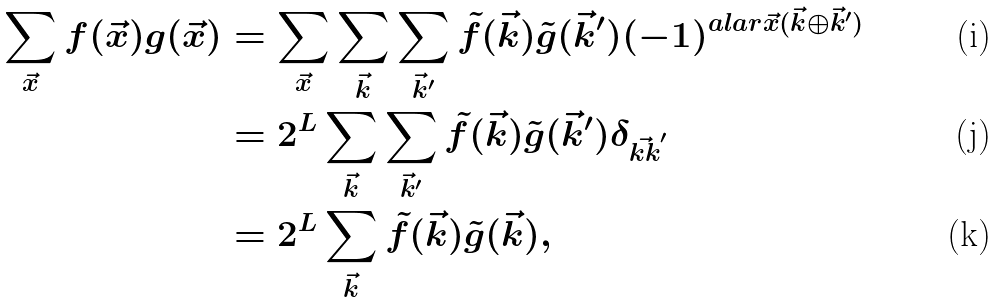Convert formula to latex. <formula><loc_0><loc_0><loc_500><loc_500>\sum _ { \vec { x } } f ( \vec { x } ) g ( \vec { x } ) & = \sum _ { \vec { x } } \sum _ { \vec { k } } \sum _ { \vec { k } ^ { \prime } } \tilde { f } ( \vec { k } ) \tilde { g } ( \vec { k } ^ { \prime } ) ( - 1 ) ^ { a l a r { \vec { x } } { ( \vec { k } \oplus \vec { k } ^ { \prime } ) } } \\ & = 2 ^ { L } \sum _ { \vec { k } } \sum _ { \vec { k } ^ { \prime } } \tilde { f } ( \vec { k } ) \tilde { g } ( \vec { k } ^ { \prime } ) \delta _ { \vec { k k } ^ { \prime } } \\ & = 2 ^ { L } \sum _ { \vec { k } } \tilde { f } ( \vec { k } ) \tilde { g } ( \vec { k } ) ,</formula> 